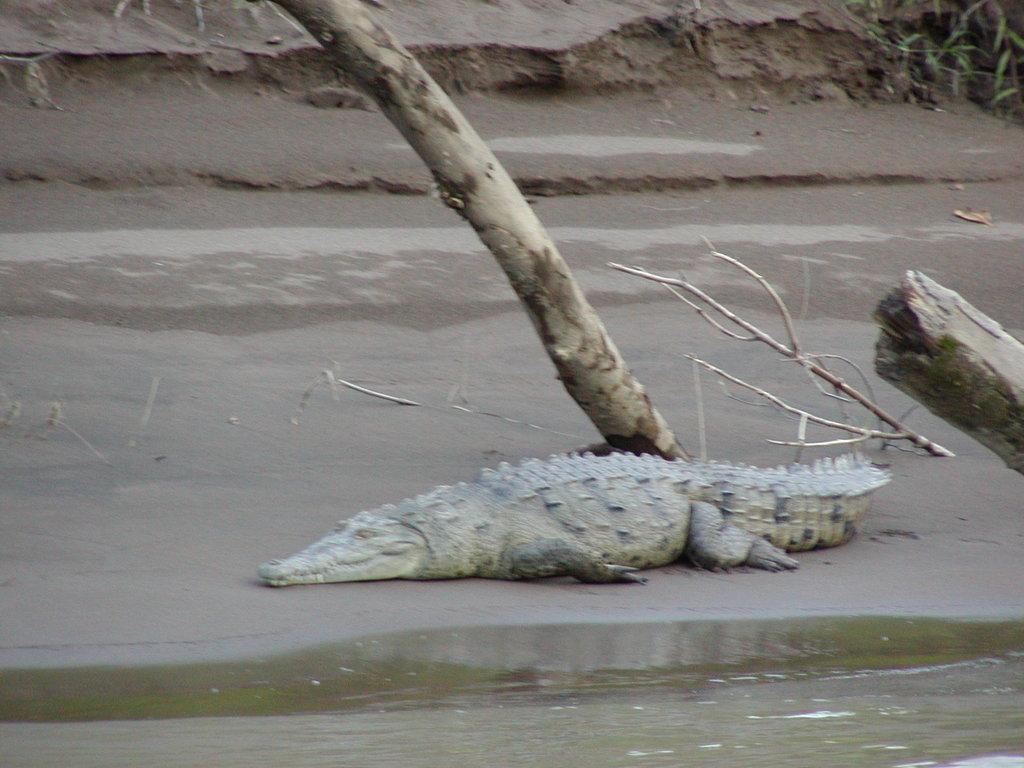Please provide a concise description of this image. In the picture I can see a crocodile on the ground. I can also see wooden objects, a plant and the water. 